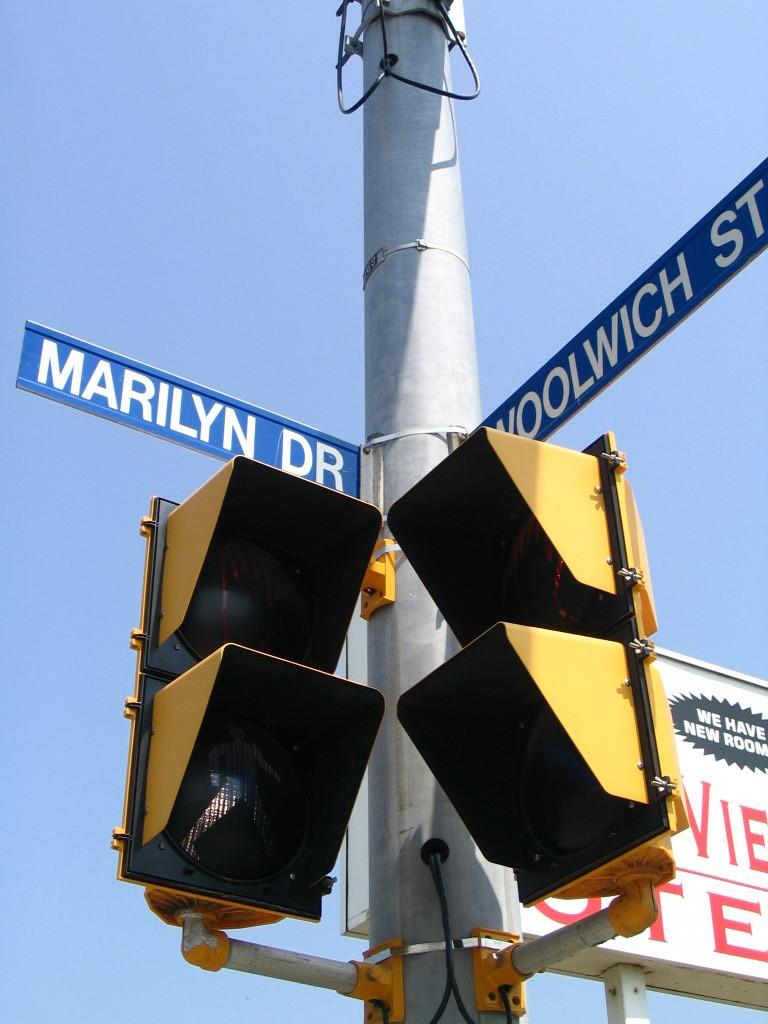Provide a one-sentence caption for the provided image. Two traffic lights on a pole at the corner of Marilyn Dr. and Woolwich St. 